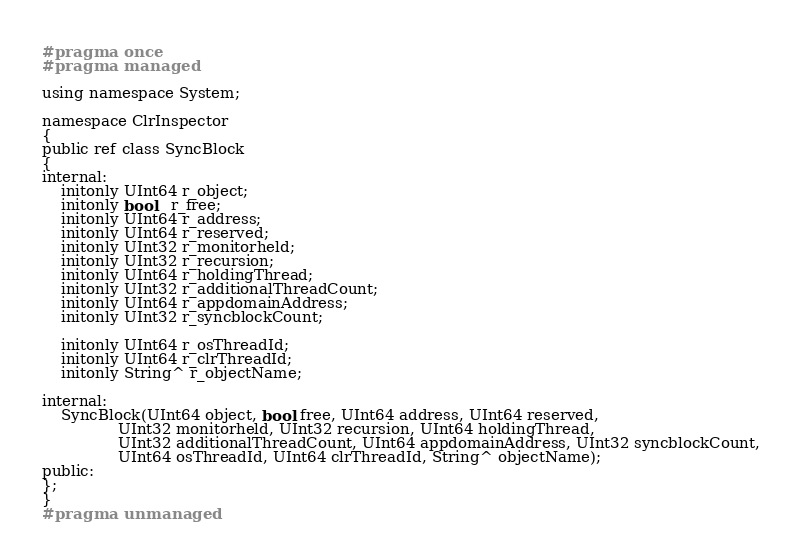<code> <loc_0><loc_0><loc_500><loc_500><_C_>#pragma once
#pragma managed

using namespace System;

namespace ClrInspector
{
public ref class SyncBlock
{
internal:
	initonly UInt64 r_object;
	initonly bool   r_free;
	initonly UInt64 r_address; 
	initonly UInt64 r_reserved; 
	initonly UInt32 r_monitorheld; 
	initonly UInt32 r_recursion; 
	initonly UInt64 r_holdingThread; 
	initonly UInt32 r_additionalThreadCount; 
	initonly UInt64 r_appdomainAddress; 
	initonly UInt32 r_syncblockCount;

	initonly UInt64 r_osThreadId; 
	initonly UInt64 r_clrThreadId; 
	initonly String^ r_objectName; 

internal:
	SyncBlock(UInt64 object, bool free, UInt64 address, UInt64 reserved, 
				UInt32 monitorheld, UInt32 recursion, UInt64 holdingThread, 
				UInt32 additionalThreadCount, UInt64 appdomainAddress, UInt32 syncblockCount,
				UInt64 osThreadId, UInt64 clrThreadId, String^ objectName);
public:
};
}
#pragma unmanaged</code> 